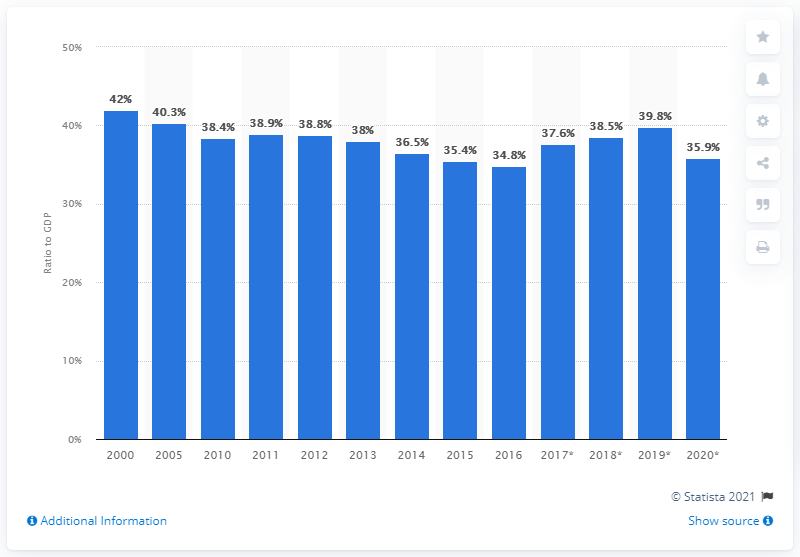List a handful of essential elements in this visual. In 2020, exports of goods and services in Finland represented 35.9% of the country's Gross Domestic Product (GDP). The value of Finnish export trade increased each year in 2016. 